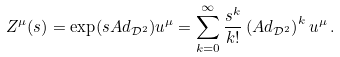<formula> <loc_0><loc_0><loc_500><loc_500>Z ^ { \mu } ( s ) = \exp ( s A d _ { \mathcal { D } ^ { 2 } } ) u ^ { \mu } = \sum _ { k = 0 } ^ { \infty } \frac { s ^ { k } } { k ! } \left ( A d _ { \mathcal { D } ^ { 2 } } \right ) ^ { k } u ^ { \mu } \, .</formula> 